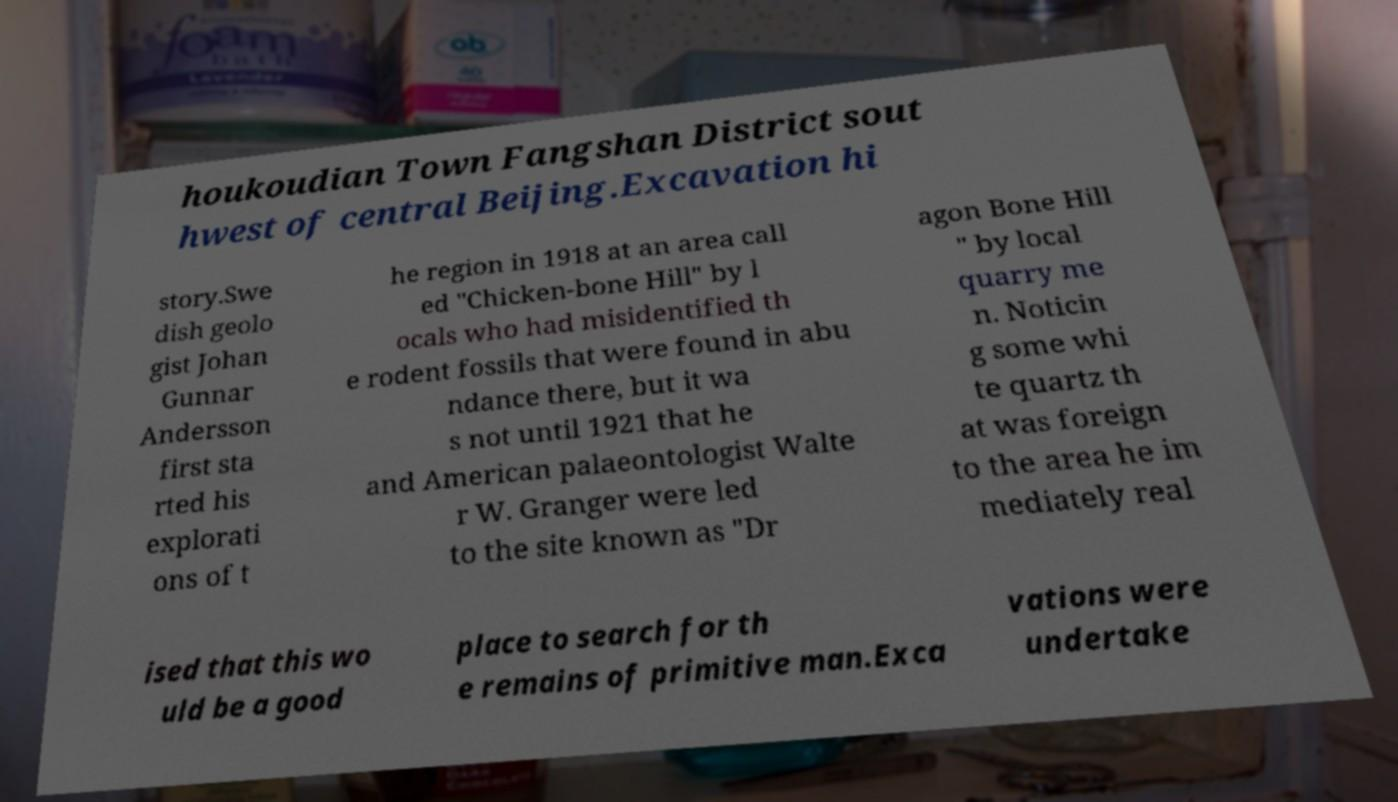Please identify and transcribe the text found in this image. houkoudian Town Fangshan District sout hwest of central Beijing.Excavation hi story.Swe dish geolo gist Johan Gunnar Andersson first sta rted his explorati ons of t he region in 1918 at an area call ed "Chicken-bone Hill" by l ocals who had misidentified th e rodent fossils that were found in abu ndance there, but it wa s not until 1921 that he and American palaeontologist Walte r W. Granger were led to the site known as "Dr agon Bone Hill " by local quarry me n. Noticin g some whi te quartz th at was foreign to the area he im mediately real ised that this wo uld be a good place to search for th e remains of primitive man.Exca vations were undertake 